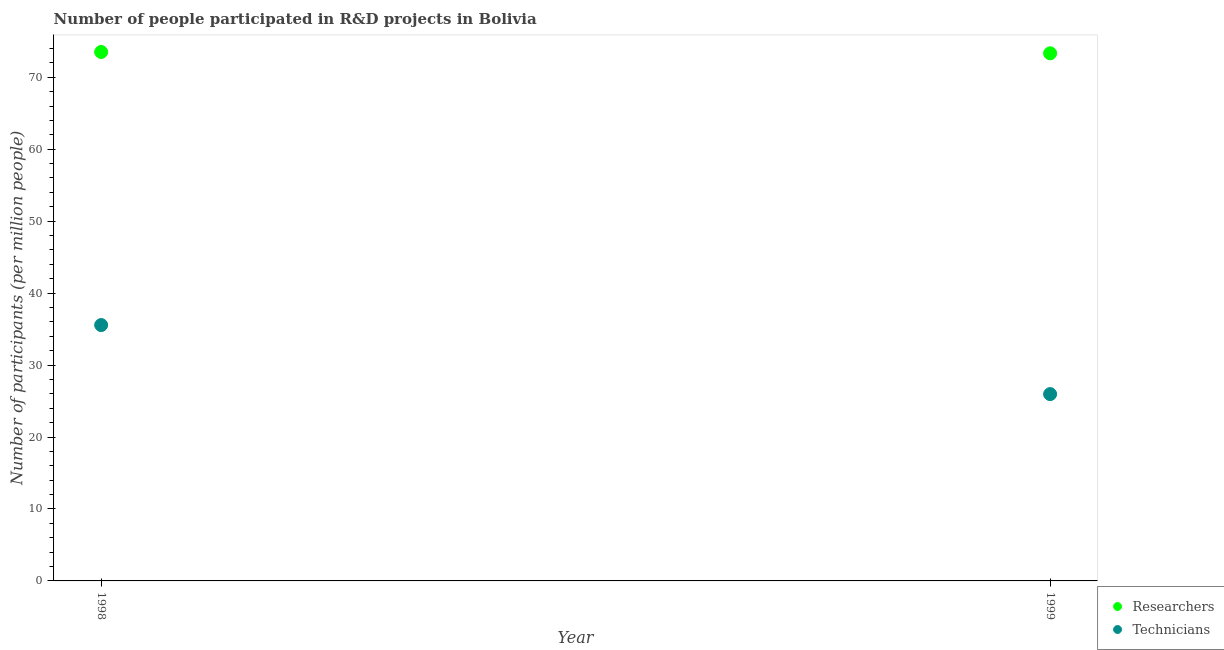What is the number of technicians in 1998?
Offer a terse response. 35.56. Across all years, what is the maximum number of researchers?
Provide a succinct answer. 73.51. Across all years, what is the minimum number of technicians?
Provide a short and direct response. 25.96. What is the total number of technicians in the graph?
Provide a short and direct response. 61.52. What is the difference between the number of researchers in 1998 and that in 1999?
Offer a very short reply. 0.18. What is the difference between the number of technicians in 1999 and the number of researchers in 1998?
Give a very brief answer. -47.55. What is the average number of researchers per year?
Make the answer very short. 73.42. In the year 1999, what is the difference between the number of researchers and number of technicians?
Ensure brevity in your answer.  47.36. In how many years, is the number of technicians greater than 70?
Provide a succinct answer. 0. What is the ratio of the number of researchers in 1998 to that in 1999?
Your response must be concise. 1. Is the number of researchers in 1998 less than that in 1999?
Your answer should be compact. No. In how many years, is the number of researchers greater than the average number of researchers taken over all years?
Make the answer very short. 1. Does the number of researchers monotonically increase over the years?
Make the answer very short. No. Is the number of technicians strictly greater than the number of researchers over the years?
Give a very brief answer. No. Is the number of technicians strictly less than the number of researchers over the years?
Make the answer very short. Yes. What is the difference between two consecutive major ticks on the Y-axis?
Offer a terse response. 10. Does the graph contain any zero values?
Offer a very short reply. No. Does the graph contain grids?
Your answer should be compact. No. How many legend labels are there?
Ensure brevity in your answer.  2. What is the title of the graph?
Offer a very short reply. Number of people participated in R&D projects in Bolivia. What is the label or title of the X-axis?
Ensure brevity in your answer.  Year. What is the label or title of the Y-axis?
Your answer should be very brief. Number of participants (per million people). What is the Number of participants (per million people) of Researchers in 1998?
Your response must be concise. 73.51. What is the Number of participants (per million people) of Technicians in 1998?
Offer a terse response. 35.56. What is the Number of participants (per million people) in Researchers in 1999?
Give a very brief answer. 73.33. What is the Number of participants (per million people) in Technicians in 1999?
Provide a succinct answer. 25.96. Across all years, what is the maximum Number of participants (per million people) in Researchers?
Make the answer very short. 73.51. Across all years, what is the maximum Number of participants (per million people) of Technicians?
Provide a short and direct response. 35.56. Across all years, what is the minimum Number of participants (per million people) in Researchers?
Your answer should be compact. 73.33. Across all years, what is the minimum Number of participants (per million people) in Technicians?
Keep it short and to the point. 25.96. What is the total Number of participants (per million people) in Researchers in the graph?
Offer a terse response. 146.83. What is the total Number of participants (per million people) of Technicians in the graph?
Your response must be concise. 61.52. What is the difference between the Number of participants (per million people) in Researchers in 1998 and that in 1999?
Provide a short and direct response. 0.18. What is the difference between the Number of participants (per million people) of Technicians in 1998 and that in 1999?
Make the answer very short. 9.6. What is the difference between the Number of participants (per million people) in Researchers in 1998 and the Number of participants (per million people) in Technicians in 1999?
Your response must be concise. 47.55. What is the average Number of participants (per million people) of Researchers per year?
Provide a succinct answer. 73.42. What is the average Number of participants (per million people) in Technicians per year?
Offer a terse response. 30.76. In the year 1998, what is the difference between the Number of participants (per million people) of Researchers and Number of participants (per million people) of Technicians?
Provide a succinct answer. 37.95. In the year 1999, what is the difference between the Number of participants (per million people) in Researchers and Number of participants (per million people) in Technicians?
Offer a very short reply. 47.36. What is the ratio of the Number of participants (per million people) in Researchers in 1998 to that in 1999?
Your answer should be compact. 1. What is the ratio of the Number of participants (per million people) of Technicians in 1998 to that in 1999?
Offer a terse response. 1.37. What is the difference between the highest and the second highest Number of participants (per million people) in Researchers?
Your answer should be very brief. 0.18. What is the difference between the highest and the second highest Number of participants (per million people) of Technicians?
Your answer should be compact. 9.6. What is the difference between the highest and the lowest Number of participants (per million people) of Researchers?
Ensure brevity in your answer.  0.18. What is the difference between the highest and the lowest Number of participants (per million people) of Technicians?
Offer a terse response. 9.6. 